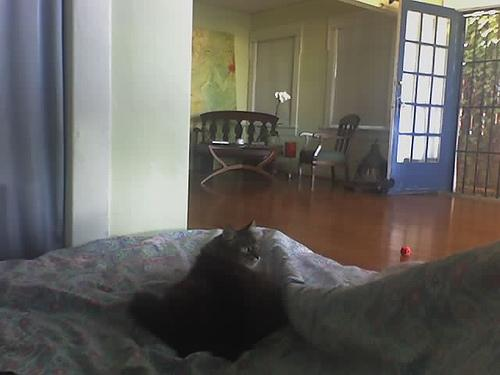The animal is resting on what? Please explain your reasoning. blanket. The animal is on a blanket. 